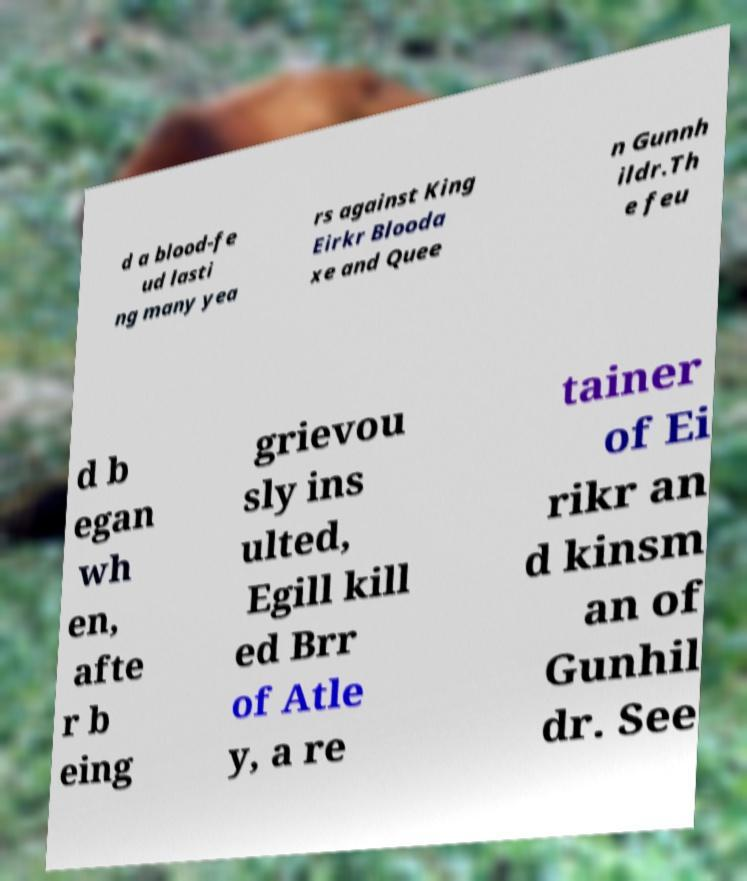Can you accurately transcribe the text from the provided image for me? d a blood-fe ud lasti ng many yea rs against King Eirkr Blooda xe and Quee n Gunnh ildr.Th e feu d b egan wh en, afte r b eing grievou sly ins ulted, Egill kill ed Brr of Atle y, a re tainer of Ei rikr an d kinsm an of Gunhil dr. See 